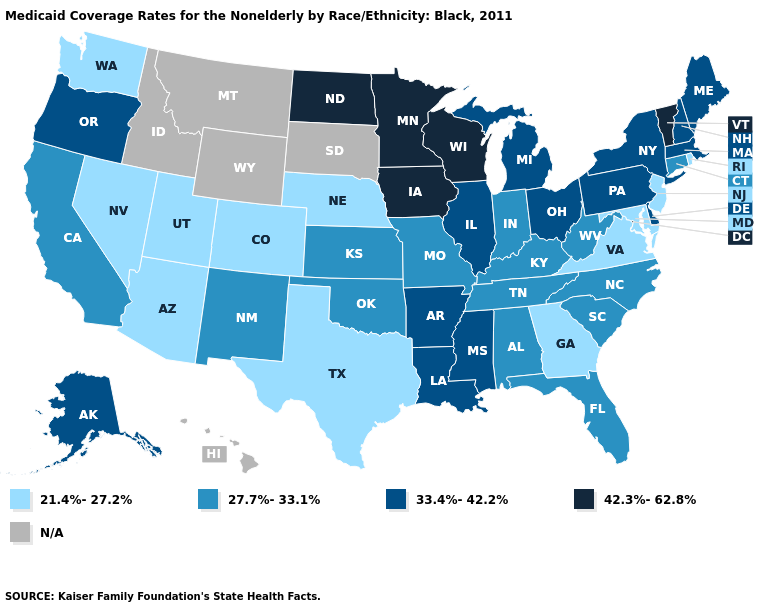What is the value of West Virginia?
Be succinct. 27.7%-33.1%. Name the states that have a value in the range 42.3%-62.8%?
Keep it brief. Iowa, Minnesota, North Dakota, Vermont, Wisconsin. Does Indiana have the lowest value in the MidWest?
Be succinct. No. Name the states that have a value in the range N/A?
Short answer required. Hawaii, Idaho, Montana, South Dakota, Wyoming. Name the states that have a value in the range N/A?
Short answer required. Hawaii, Idaho, Montana, South Dakota, Wyoming. Name the states that have a value in the range 27.7%-33.1%?
Write a very short answer. Alabama, California, Connecticut, Florida, Indiana, Kansas, Kentucky, Missouri, New Mexico, North Carolina, Oklahoma, South Carolina, Tennessee, West Virginia. Does the first symbol in the legend represent the smallest category?
Answer briefly. Yes. What is the lowest value in the Northeast?
Concise answer only. 21.4%-27.2%. What is the value of West Virginia?
Be succinct. 27.7%-33.1%. Name the states that have a value in the range 21.4%-27.2%?
Give a very brief answer. Arizona, Colorado, Georgia, Maryland, Nebraska, Nevada, New Jersey, Rhode Island, Texas, Utah, Virginia, Washington. Name the states that have a value in the range 42.3%-62.8%?
Concise answer only. Iowa, Minnesota, North Dakota, Vermont, Wisconsin. What is the value of North Carolina?
Write a very short answer. 27.7%-33.1%. Which states have the highest value in the USA?
Keep it brief. Iowa, Minnesota, North Dakota, Vermont, Wisconsin. Among the states that border South Carolina , does Georgia have the lowest value?
Answer briefly. Yes. Name the states that have a value in the range 33.4%-42.2%?
Answer briefly. Alaska, Arkansas, Delaware, Illinois, Louisiana, Maine, Massachusetts, Michigan, Mississippi, New Hampshire, New York, Ohio, Oregon, Pennsylvania. 